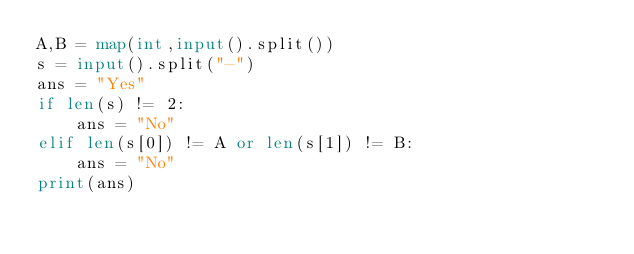Convert code to text. <code><loc_0><loc_0><loc_500><loc_500><_Python_>A,B = map(int,input().split())
s = input().split("-")
ans = "Yes"
if len(s) != 2:
    ans = "No"
elif len(s[0]) != A or len(s[1]) != B:
    ans = "No"
print(ans)</code> 